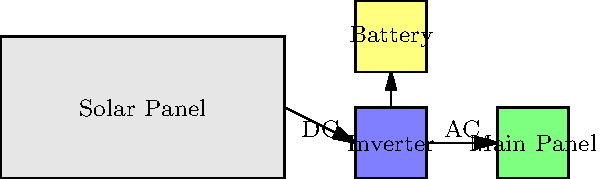In the solar panel installation diagram for your charity facility, what is the primary function of the component labeled "Inverter" in the system? To understand the function of the inverter in this solar panel installation, let's break down the system components and their roles:

1. Solar Panel: This is where sunlight is converted into electrical energy in the form of direct current (DC).

2. Inverter: This is the component in question. It receives the DC electricity from the solar panel.

3. Battery: This stores excess energy for later use.

4. Main Panel: This distributes electricity to the facility.

5. Connections: We can see that DC power flows from the solar panel to the inverter, and AC power flows from the inverter to the main panel.

The key point here is the change from DC to AC. Most electrical appliances and the power grid use alternating current (AC), but solar panels produce direct current (DC). Therefore, the primary function of the inverter is to convert the DC electricity produced by the solar panels into AC electricity that can be used by the facility or fed back into the grid.

This conversion is crucial because:
a) It allows the solar-generated electricity to be compatible with standard electrical systems.
b) It enables the system to send excess power back to the grid if needed.
c) It helps in regulating the voltage and frequency of the electricity to match grid requirements.
Answer: Convert DC to AC 